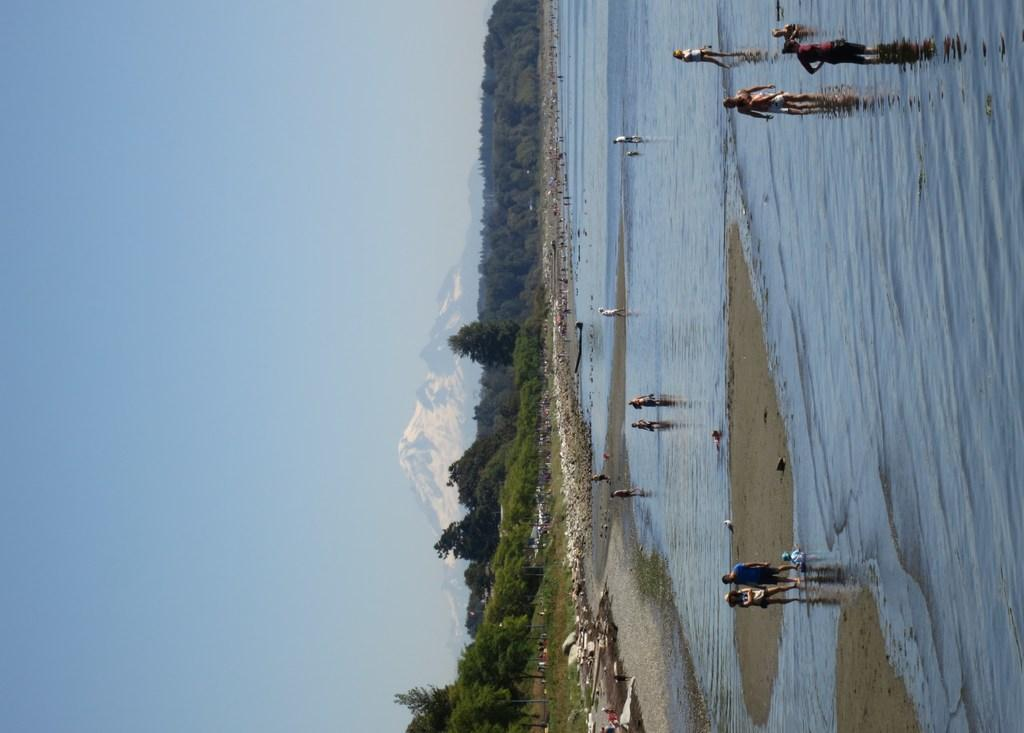What is the main setting of the image? The main setting of the image is a beach. What can be seen in the middle of the image? There are trees in the middle of the image. What is visible on the left side of the image? There is a sky visible on the left side of the image. What type of star can be seen in the flesh in the image? There is no star or flesh present in the image; it features a beach setting with trees and a sky. 